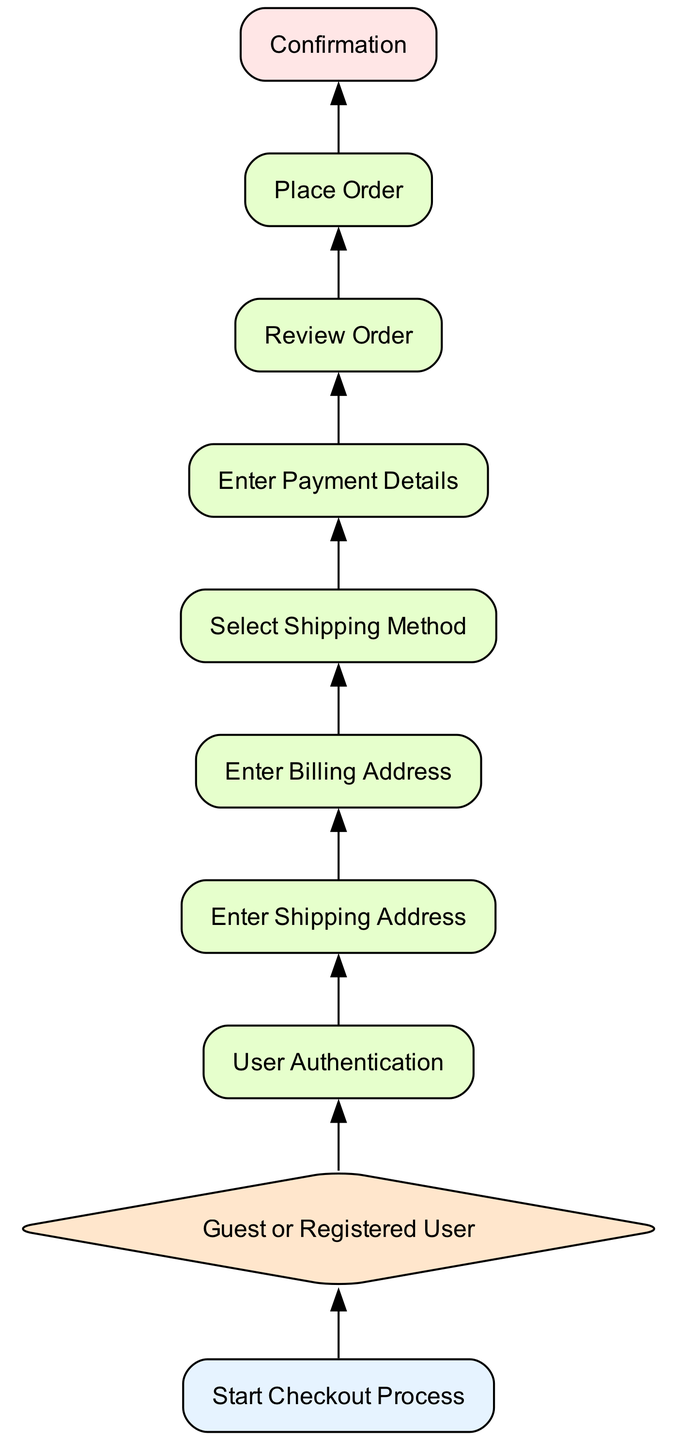What is the first step in the checkout process? The flowchart starts with the "Start Checkout Process" node, which indicates the initiation of the checkout process when a customer selects 'Checkout' from their cart.
Answer: Start Checkout Process How many decision nodes are present in the diagram? There is 1 decision node, which is the "Guest or Registered User" node that determines the customer's checkout type.
Answer: 1 What process follows user authentication? After the "User Authentication" process, the next step is "Enter Shipping Address", where the customer inputs their shipping information.
Answer: Enter Shipping Address What happens after entering payment details? After entering payment details, the customer proceeds to "Review Order", where they can review a summary of their order before finalizing it.
Answer: Review Order What is the last step in the customer checkout process? The final step in the customer checkout process is the "Confirmation" node, where order confirmation is displayed and an email is sent to the customer.
Answer: Confirmation What information is collected after "Enter Shipping Address"? Following "Enter Shipping Address", the next step is "Enter Billing Address", which allows customers to input their billing address information.
Answer: Enter Billing Address What decision does the checkout process start with? The checkout process begins with a decision on whether the customer is a guest or a registered user, found in the "Guest or Registered User" node.
Answer: Guest or Registered User Which steps occur before placing an order? Before placing an order, customers must complete the "Review Order" step, which details their order summary, and "Enter Payment Details", where payment information is inputted.
Answer: Review Order, Enter Payment Details 